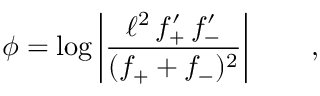<formula> <loc_0><loc_0><loc_500><loc_500>\phi = \log \left | \frac { \ell ^ { 2 } \, f _ { + } ^ { \prime } \, f _ { - } ^ { \prime } } { ( f _ { + } + f _ { - } ) ^ { 2 } } \right | \quad ,</formula> 